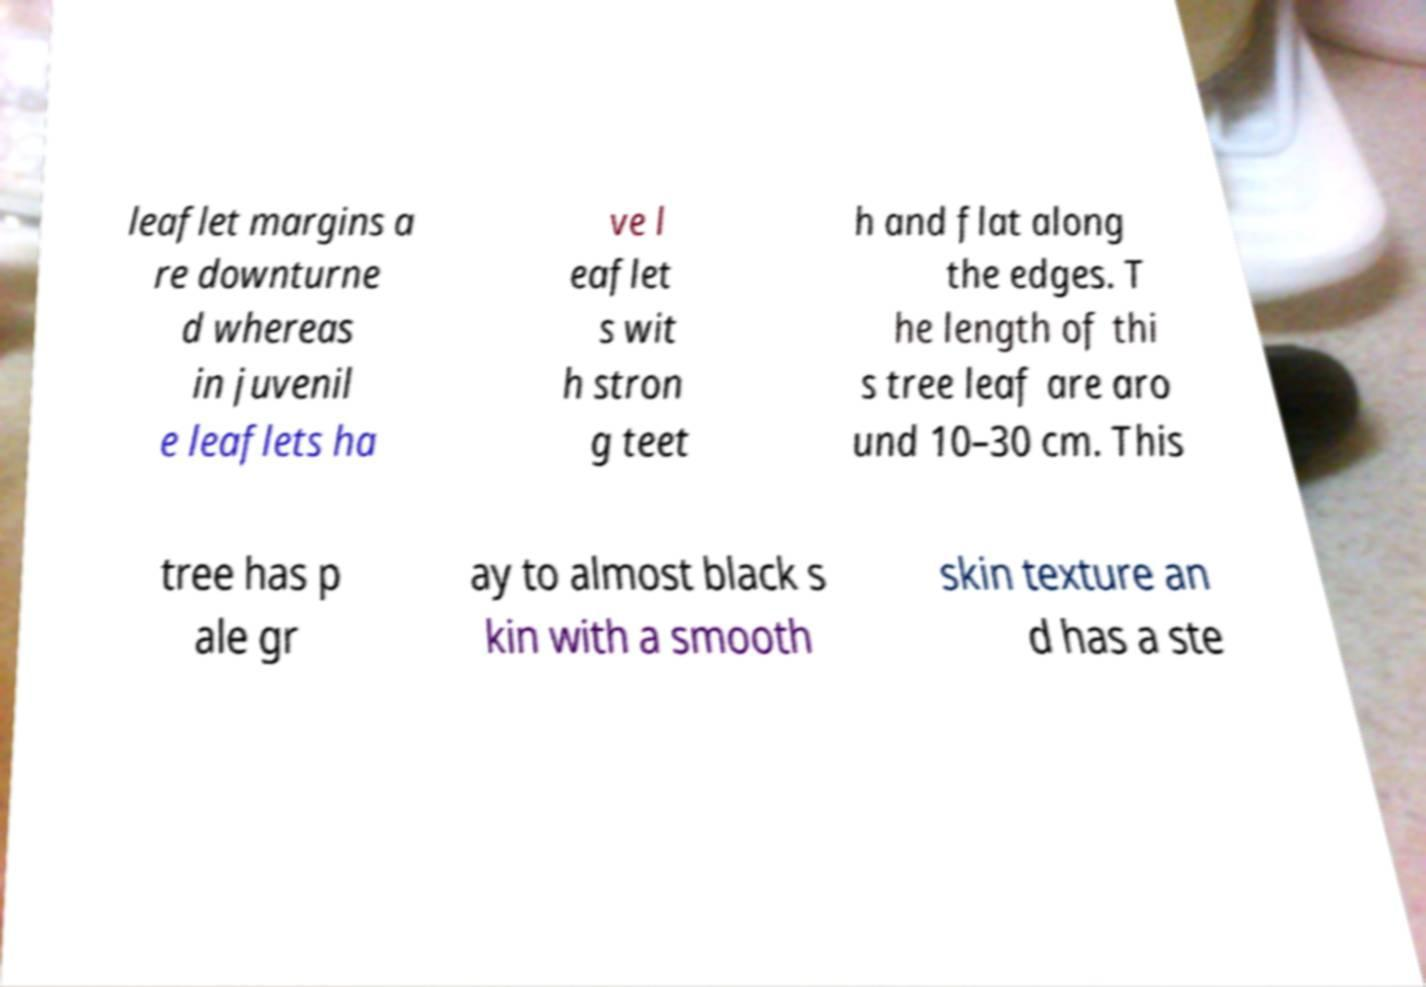Please read and relay the text visible in this image. What does it say? leaflet margins a re downturne d whereas in juvenil e leaflets ha ve l eaflet s wit h stron g teet h and flat along the edges. T he length of thi s tree leaf are aro und 10–30 cm. This tree has p ale gr ay to almost black s kin with a smooth skin texture an d has a ste 